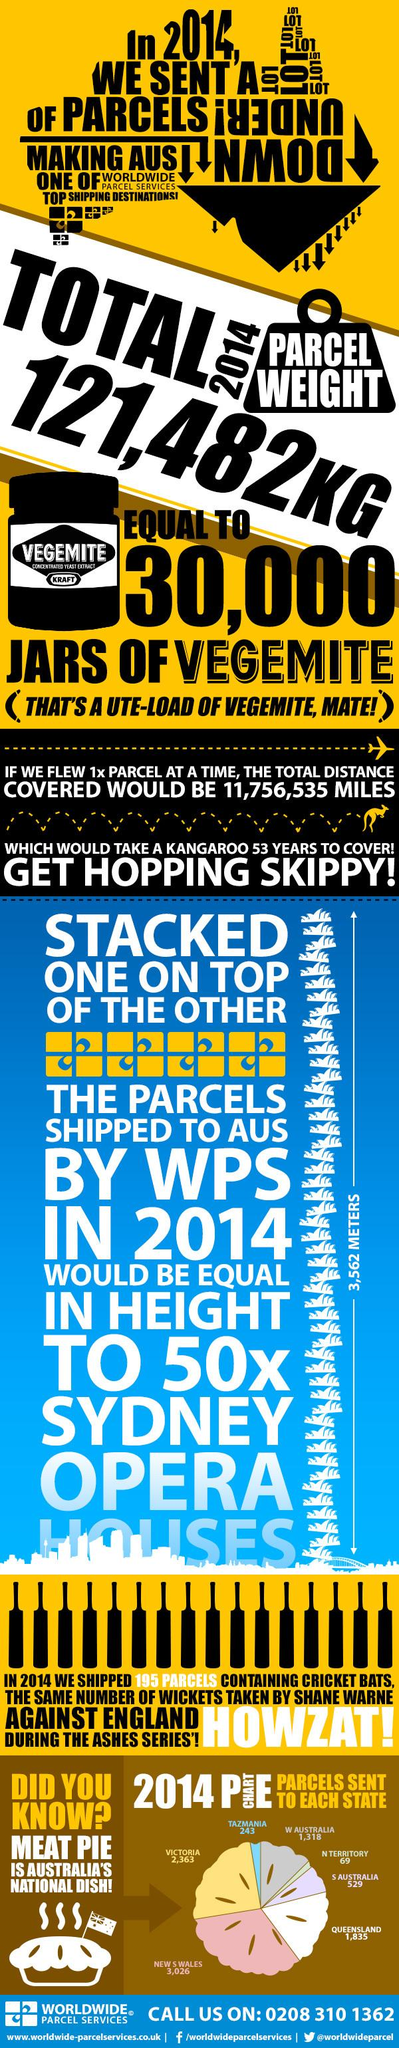Draw attention to some important aspects in this diagram. In 2014, the Northern Territory received the fewest number of meat pie parcels out of all the states in Australia. In the year 2014, the total weight of parcels sent by Australia was 121,482 kilograms. In 2014, a total of 243 meat pie parcels were sent to Tasmania. In 2014, a total of 2,363 meat pie parcels were sent to Victoria. Australia's national dish is the meat pie. 